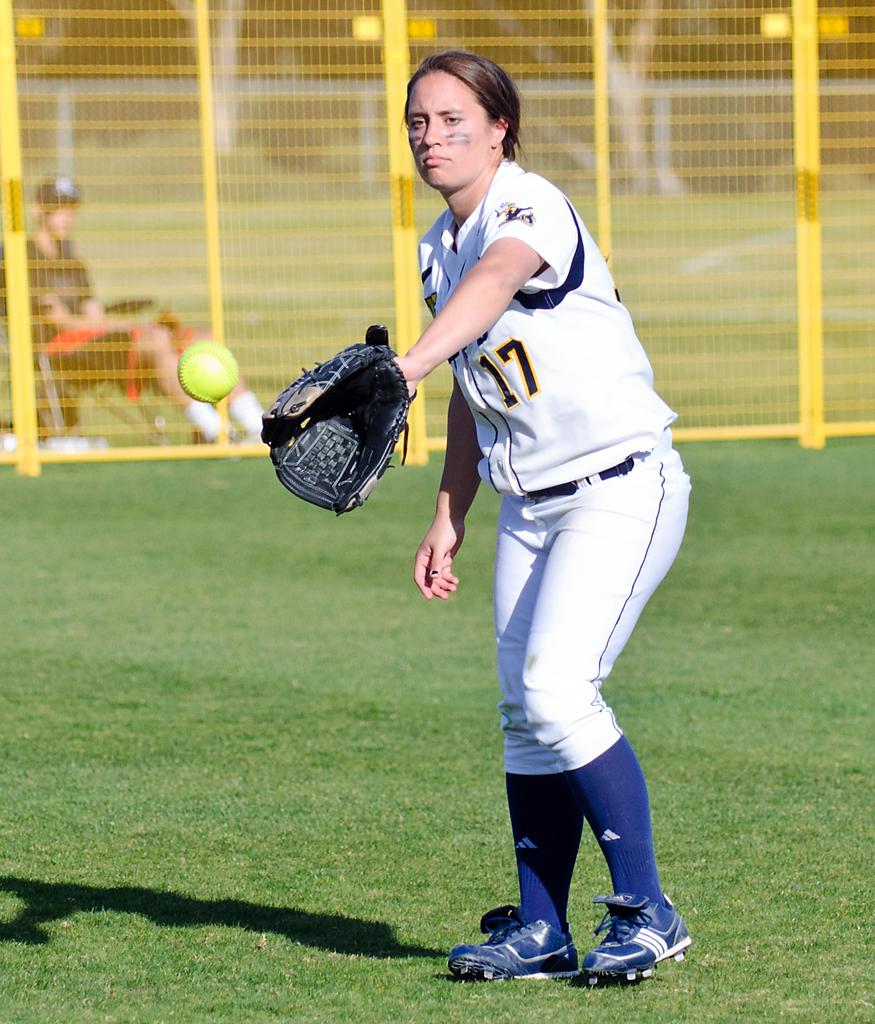What jersey number is this player?
Offer a terse response. 17. What is her number?
Keep it short and to the point. 17. 